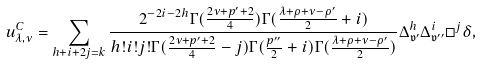<formula> <loc_0><loc_0><loc_500><loc_500>u ^ { C } _ { \lambda , \nu } = \sum _ { h + i + 2 j = k } \frac { 2 ^ { - 2 i - 2 h } \Gamma ( \frac { 2 \nu + p ^ { \prime } + 2 } { 4 } ) \Gamma ( \frac { \lambda + \rho + \nu - \rho ^ { \prime } } { 2 } + i ) } { h ! i ! j ! \Gamma ( \frac { 2 \nu + p ^ { \prime } + 2 } { 4 } - j ) \Gamma ( \frac { p ^ { \prime \prime } } { 2 } + i ) \Gamma ( \frac { \lambda + \rho + \nu - \rho ^ { \prime } } { 2 } ) } \Delta _ { \mathfrak { v } ^ { \prime } } ^ { h } \Delta _ { \mathfrak { v } ^ { \prime \prime } } ^ { i } \square ^ { j } \delta ,</formula> 